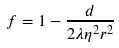<formula> <loc_0><loc_0><loc_500><loc_500>f = 1 - \frac { d } { 2 \lambda \eta ^ { 2 } r ^ { 2 } }</formula> 